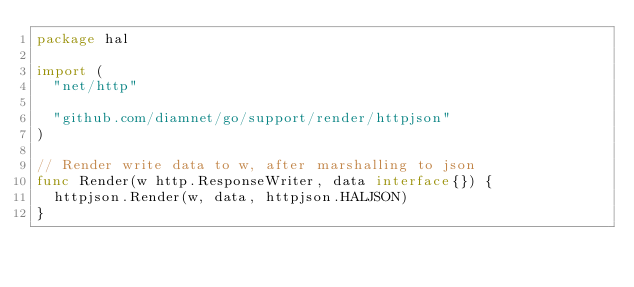Convert code to text. <code><loc_0><loc_0><loc_500><loc_500><_Go_>package hal

import (
	"net/http"

	"github.com/diamnet/go/support/render/httpjson"
)

// Render write data to w, after marshalling to json
func Render(w http.ResponseWriter, data interface{}) {
	httpjson.Render(w, data, httpjson.HALJSON)
}
</code> 